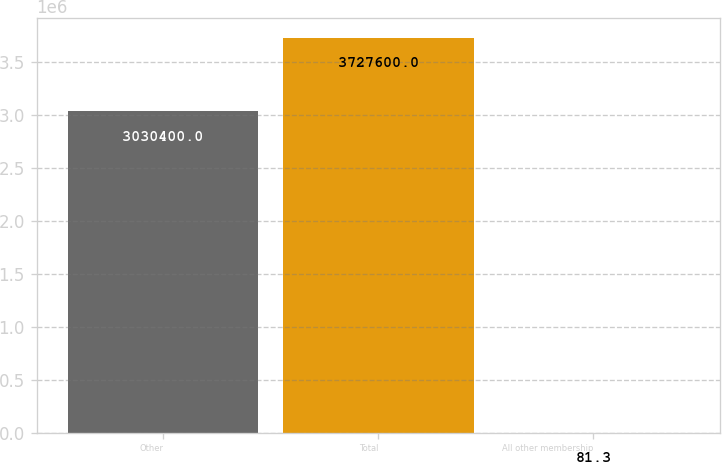<chart> <loc_0><loc_0><loc_500><loc_500><bar_chart><fcel>Other<fcel>Total<fcel>All other membership<nl><fcel>3.0304e+06<fcel>3.7276e+06<fcel>81.3<nl></chart> 